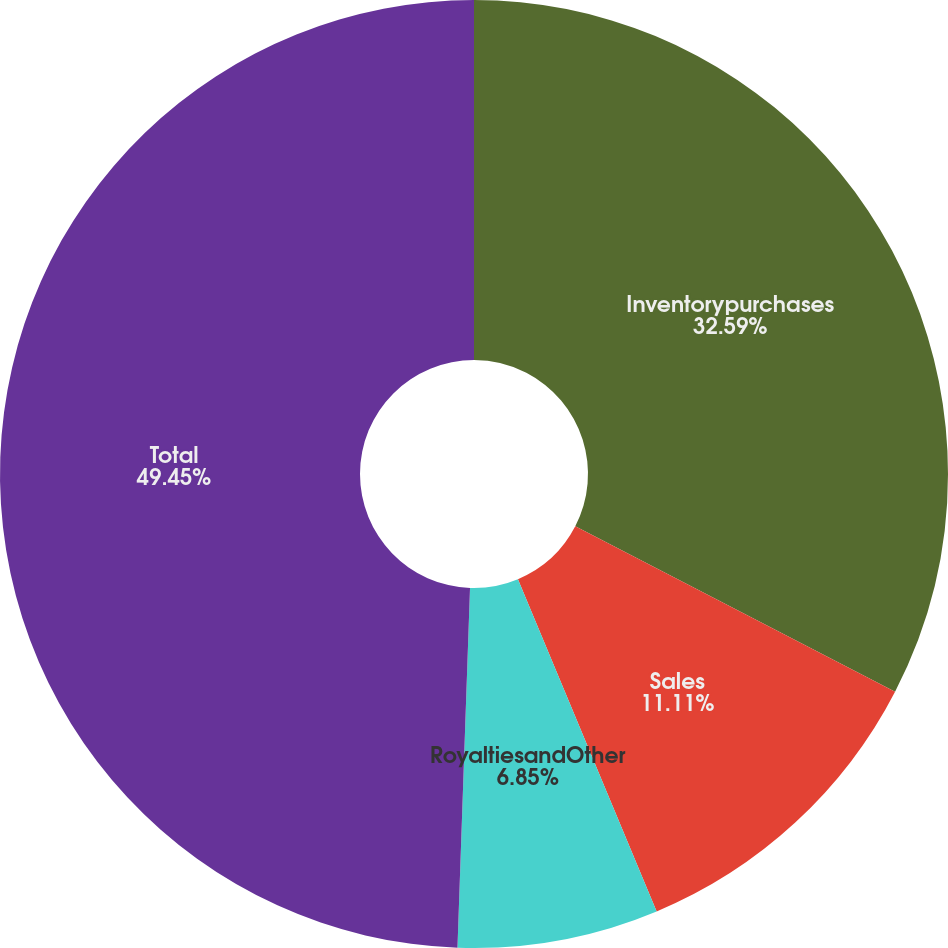Convert chart. <chart><loc_0><loc_0><loc_500><loc_500><pie_chart><fcel>Inventorypurchases<fcel>Sales<fcel>RoyaltiesandOther<fcel>Total<nl><fcel>32.59%<fcel>11.11%<fcel>6.85%<fcel>49.44%<nl></chart> 